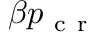<formula> <loc_0><loc_0><loc_500><loc_500>\beta p _ { c r }</formula> 